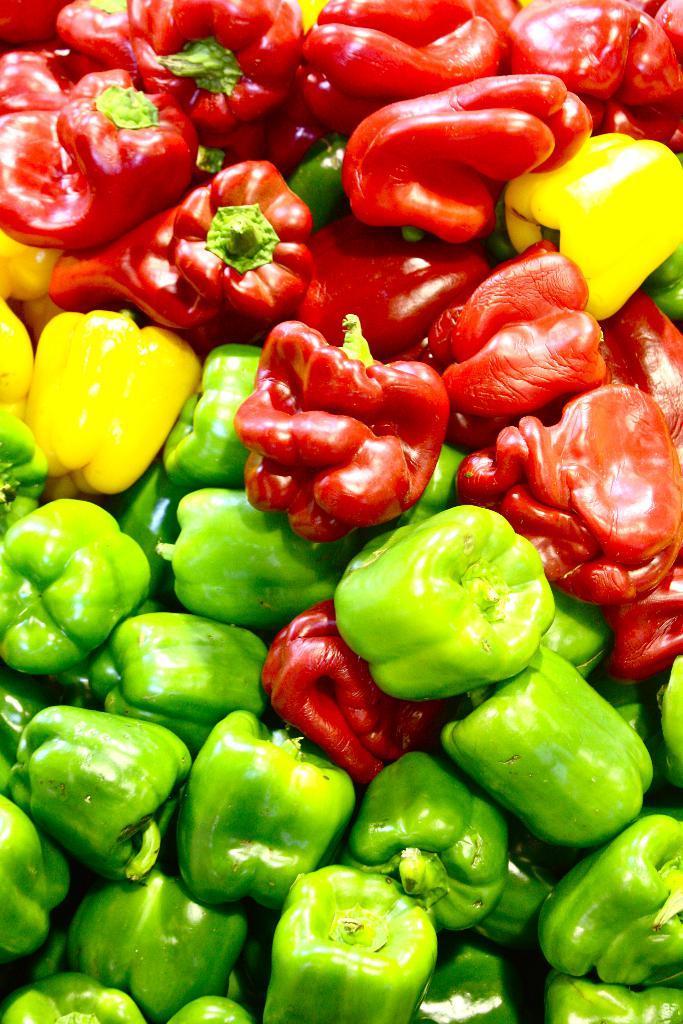Describe this image in one or two sentences. In this picture we can observe different colors of capsicums. We can observe yellow, green and red color capsicums. 